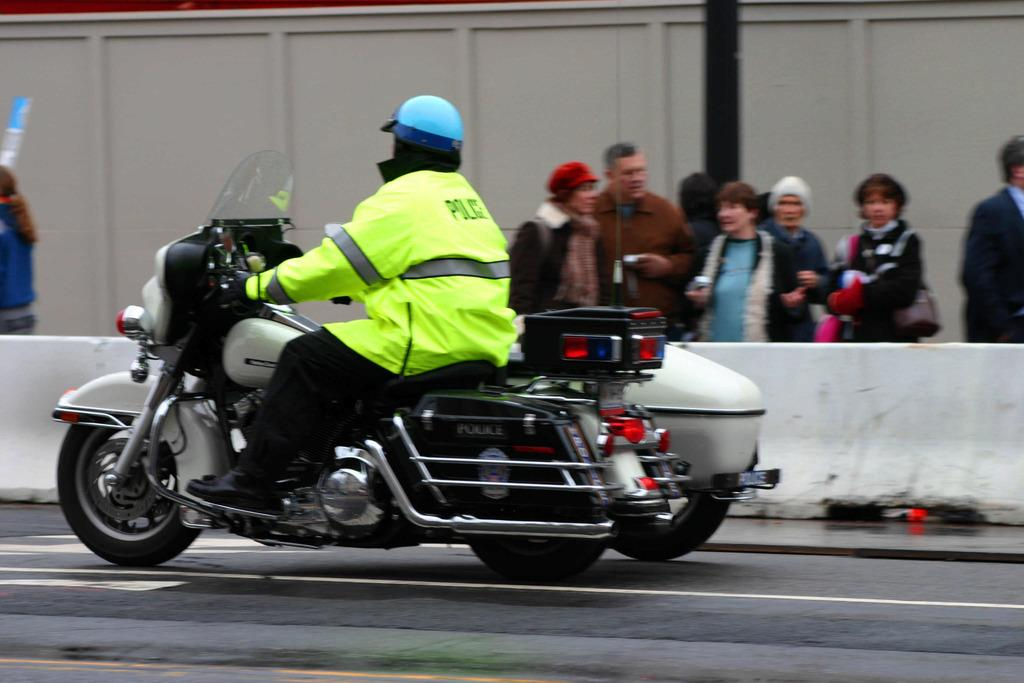What is happening in the foreground of the image? There is a person on a vehicle in the foreground. What can be seen in the background of the image? There are people and a boundary in the background. Can you describe any structures in the background? Yes, there is a wooden wall and a pole in the background. What advertisement can be seen on the top of the wooden wall in the image? There is no advertisement visible on the wooden wall or any other part of the image. 